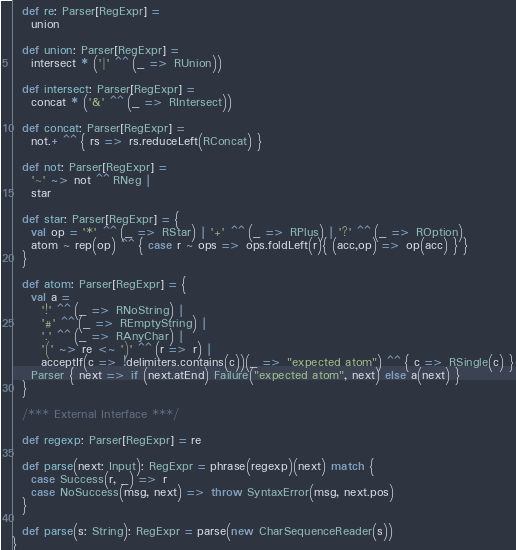<code> <loc_0><loc_0><loc_500><loc_500><_Scala_>  def re: Parser[RegExpr] =
    union
    
  def union: Parser[RegExpr] =
    intersect * ('|' ^^ (_ => RUnion))
  
  def intersect: Parser[RegExpr] =
    concat * ('&' ^^ (_ => RIntersect))
    
  def concat: Parser[RegExpr] =
    not.+ ^^ { rs => rs.reduceLeft(RConcat) }
        
  def not: Parser[RegExpr] =
    '~' ~> not ^^ RNeg |
    star
    
  def star: Parser[RegExpr] = {
    val op = '*' ^^ (_ => RStar) | '+' ^^ (_ => RPlus) | '?' ^^ (_ => ROption)
    atom ~ rep(op) ^^ { case r ~ ops => ops.foldLeft(r){ (acc,op) => op(acc) } }
  }

  def atom: Parser[RegExpr] = {
    val a =
      '!' ^^ (_ => RNoString) |
      '#' ^^ (_ => REmptyString) |
      '.' ^^ (_ => RAnyChar) |
      '(' ~> re <~ ')' ^^ (r => r) |
      acceptIf(c => !delimiters.contains(c))(_ => "expected atom") ^^ { c => RSingle(c) }
    Parser { next => if (next.atEnd) Failure("expected atom", next) else a(next) }
  }

  /*** External Interface ***/
  
  def regexp: Parser[RegExpr] = re
    
  def parse(next: Input): RegExpr = phrase(regexp)(next) match {
    case Success(r, _) => r
    case NoSuccess(msg, next) => throw SyntaxError(msg, next.pos)
  }

  def parse(s: String): RegExpr = parse(new CharSequenceReader(s))
}</code> 